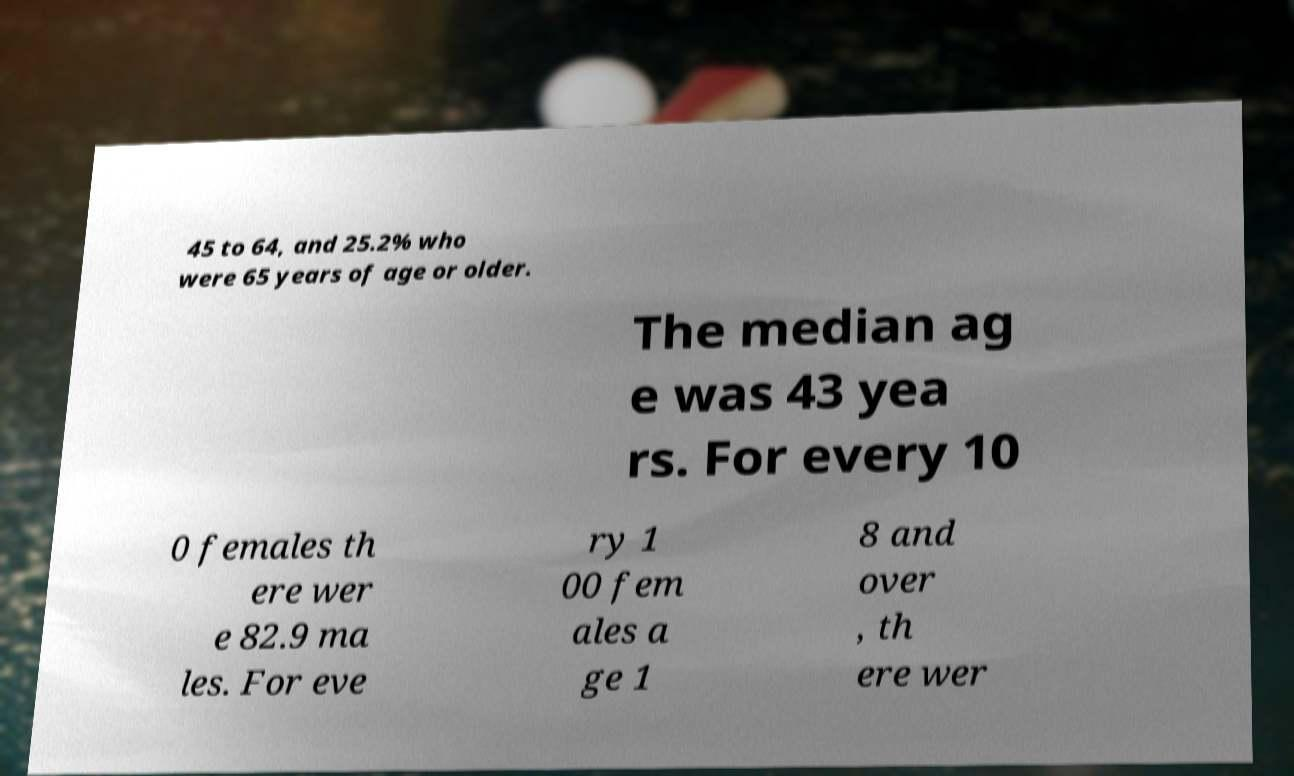I need the written content from this picture converted into text. Can you do that? 45 to 64, and 25.2% who were 65 years of age or older. The median ag e was 43 yea rs. For every 10 0 females th ere wer e 82.9 ma les. For eve ry 1 00 fem ales a ge 1 8 and over , th ere wer 